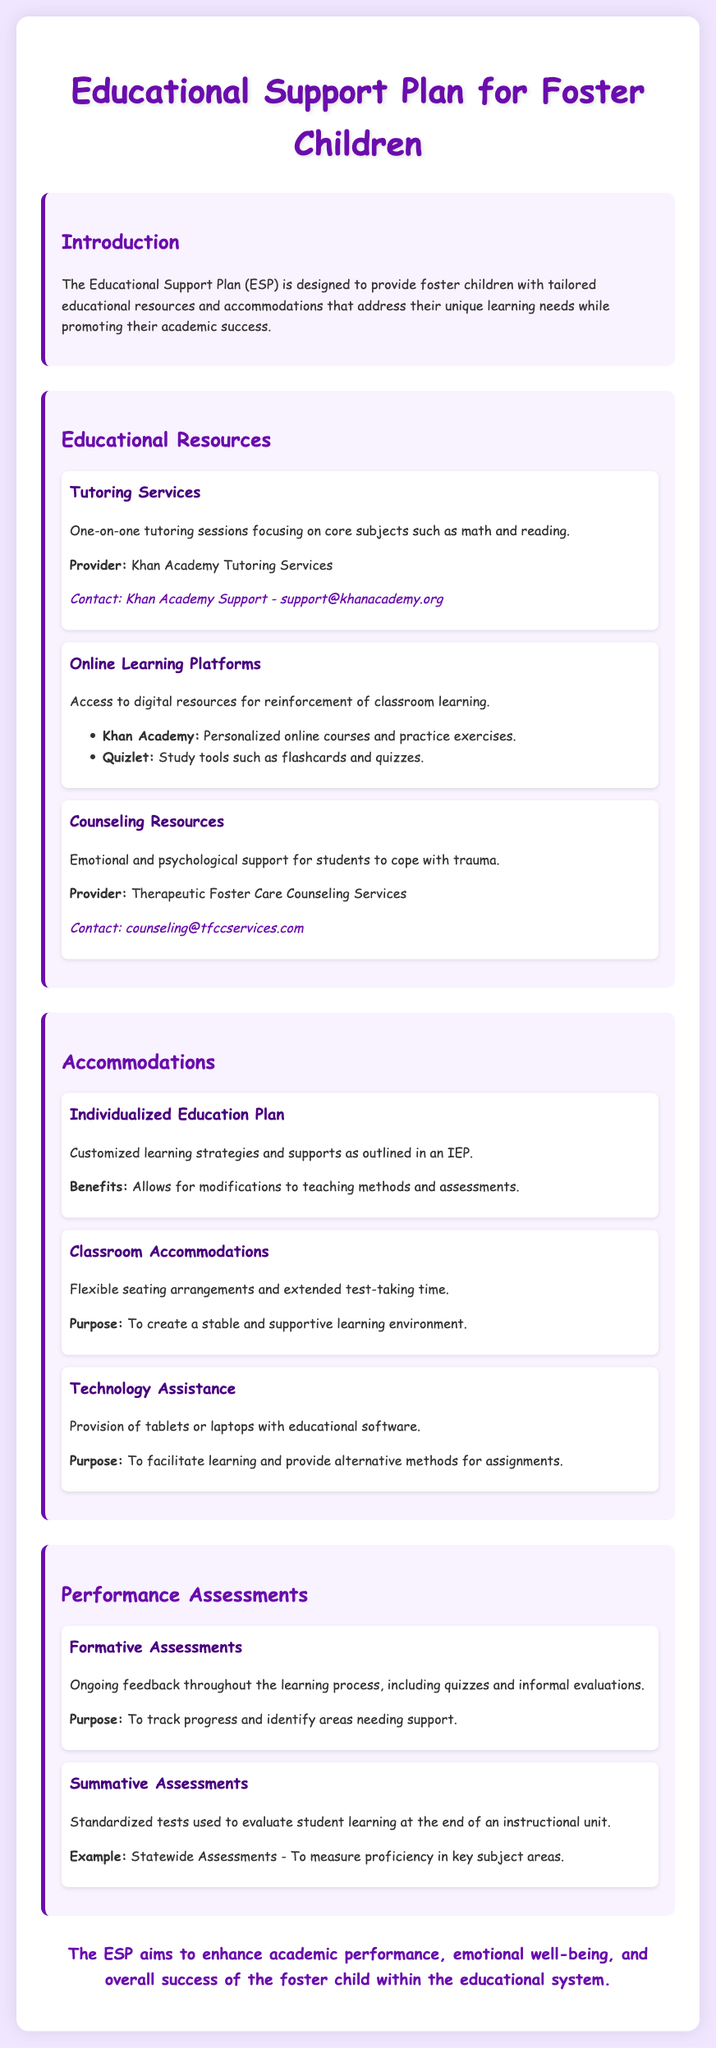What is the main purpose of the Educational Support Plan? The purpose of the ESP is to provide support for foster children to address their unique learning needs while promoting academic success.
Answer: to provide support for foster children Who provides tutoring services? The document states that Khan Academy provides tutoring services for foster children.
Answer: Khan Academy Tutoring Services What are two online learning platforms mentioned? The document lists Khan Academy and Quizlet as online learning platforms.
Answer: Khan Academy, Quizlet What type of support does Counseling Resources offer? The Counseling Resources provide emotional and psychological support for students to cope with trauma.
Answer: emotional and psychological support What is one of the benefits of an Individualized Education Plan? The benefit of an IEP mentioned includes allowing modifications to teaching methods and assessments.
Answer: modifications to teaching methods and assessments What is the purpose of classroom accommodations? Classroom accommodations are designed to create a stable and supportive learning environment.
Answer: create a stable and supportive learning environment What does formative assessment track? Formative assessments are used to track student progress and identify areas needing support.
Answer: student progress What is an example of a summative assessment mentioned in the document? The document gives statewide assessments as an example of summative assessments used to evaluate student learning.
Answer: Statewide Assessments What type of information does the ESP aim to enhance? The ESP aims to enhance academic performance, emotional well-being, and overall success of the foster child.
Answer: academic performance 